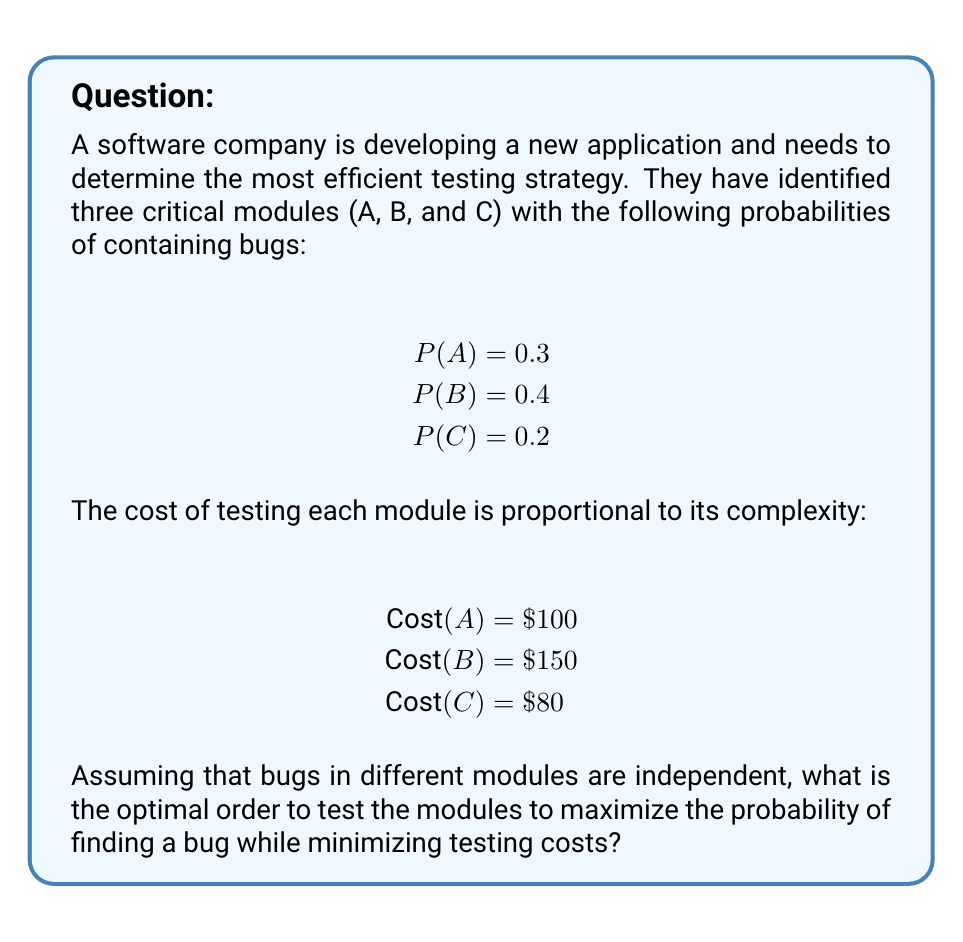Give your solution to this math problem. To determine the most efficient testing strategy, we need to calculate the expected value (EV) of finding a bug per unit cost for each module. This approach ensures we maximize the probability of finding a bug while minimizing testing costs.

Step 1: Calculate the EV per unit cost for each module.

For module A:
$$ EV_A = \frac{P(A)}{Cost(A)} = \frac{0.3}{100} = 0.003 $$

For module B:
$$ EV_B = \frac{P(B)}{Cost(B)} = \frac{0.4}{150} \approx 0.00267 $$

For module C:
$$ EV_C = \frac{P(C)}{Cost(C)} = \frac{0.2}{80} = 0.0025 $$

Step 2: Rank the modules based on their EV per unit cost.

A: 0.003
B: 0.00267
C: 0.0025

Step 3: Determine the optimal testing order.

The optimal order is to test the modules in descending order of their EV per unit cost. This strategy maximizes the probability of finding a bug early while minimizing the overall testing cost.

Therefore, the optimal testing order is:
1. Module A
2. Module B
3. Module C

This approach ensures that we prioritize testing the modules with the highest probability of containing bugs relative to their testing cost, maximizing the efficiency of our testing strategy.
Answer: A, B, C 